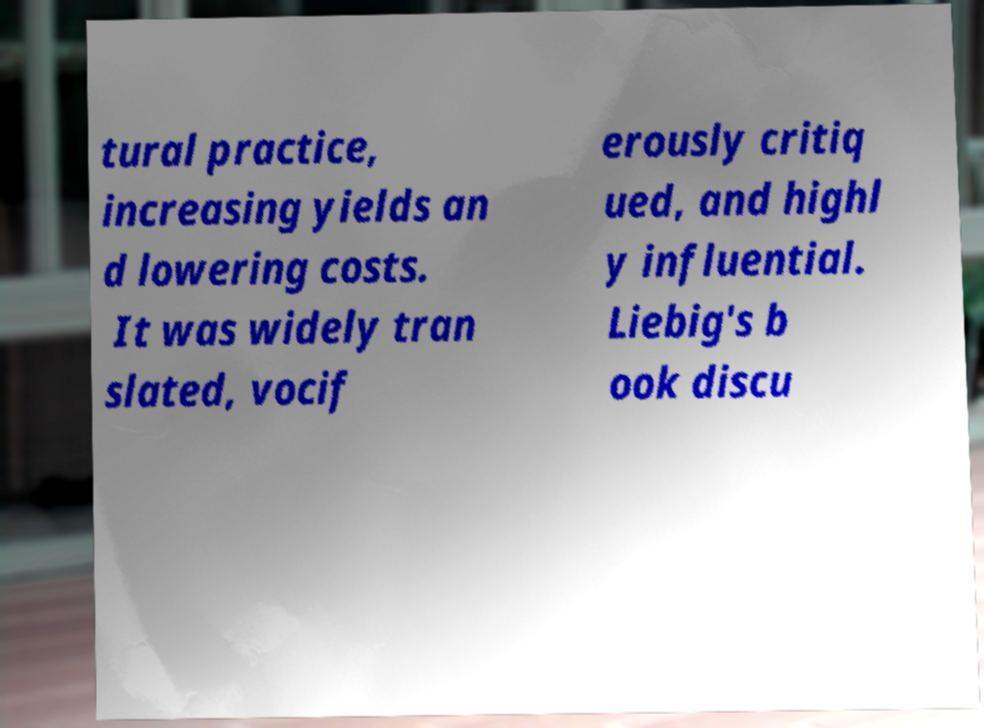Could you assist in decoding the text presented in this image and type it out clearly? tural practice, increasing yields an d lowering costs. It was widely tran slated, vocif erously critiq ued, and highl y influential. Liebig's b ook discu 